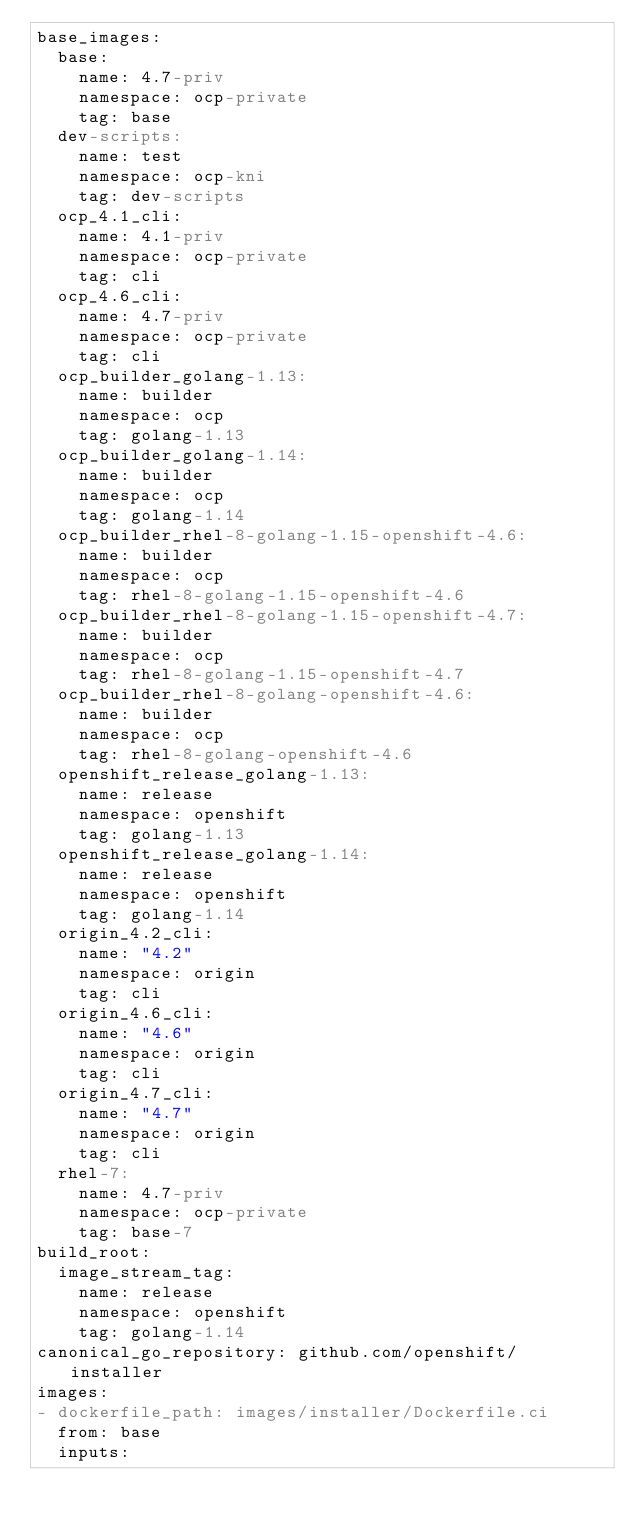<code> <loc_0><loc_0><loc_500><loc_500><_YAML_>base_images:
  base:
    name: 4.7-priv
    namespace: ocp-private
    tag: base
  dev-scripts:
    name: test
    namespace: ocp-kni
    tag: dev-scripts
  ocp_4.1_cli:
    name: 4.1-priv
    namespace: ocp-private
    tag: cli
  ocp_4.6_cli:
    name: 4.7-priv
    namespace: ocp-private
    tag: cli
  ocp_builder_golang-1.13:
    name: builder
    namespace: ocp
    tag: golang-1.13
  ocp_builder_golang-1.14:
    name: builder
    namespace: ocp
    tag: golang-1.14
  ocp_builder_rhel-8-golang-1.15-openshift-4.6:
    name: builder
    namespace: ocp
    tag: rhel-8-golang-1.15-openshift-4.6
  ocp_builder_rhel-8-golang-1.15-openshift-4.7:
    name: builder
    namespace: ocp
    tag: rhel-8-golang-1.15-openshift-4.7
  ocp_builder_rhel-8-golang-openshift-4.6:
    name: builder
    namespace: ocp
    tag: rhel-8-golang-openshift-4.6
  openshift_release_golang-1.13:
    name: release
    namespace: openshift
    tag: golang-1.13
  openshift_release_golang-1.14:
    name: release
    namespace: openshift
    tag: golang-1.14
  origin_4.2_cli:
    name: "4.2"
    namespace: origin
    tag: cli
  origin_4.6_cli:
    name: "4.6"
    namespace: origin
    tag: cli
  origin_4.7_cli:
    name: "4.7"
    namespace: origin
    tag: cli
  rhel-7:
    name: 4.7-priv
    namespace: ocp-private
    tag: base-7
build_root:
  image_stream_tag:
    name: release
    namespace: openshift
    tag: golang-1.14
canonical_go_repository: github.com/openshift/installer
images:
- dockerfile_path: images/installer/Dockerfile.ci
  from: base
  inputs:</code> 